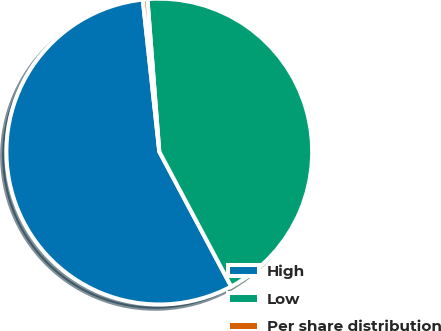<chart> <loc_0><loc_0><loc_500><loc_500><pie_chart><fcel>High<fcel>Low<fcel>Per share distribution<nl><fcel>56.07%<fcel>43.44%<fcel>0.49%<nl></chart> 